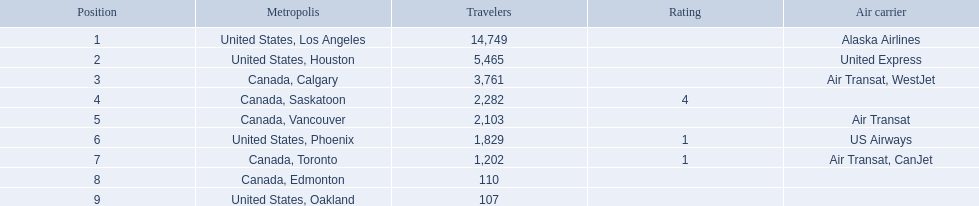What numbers are in the passengers column? 14,749, 5,465, 3,761, 2,282, 2,103, 1,829, 1,202, 110, 107. Which number is the lowest number in the passengers column? 107. What city is associated with this number? United States, Oakland. 